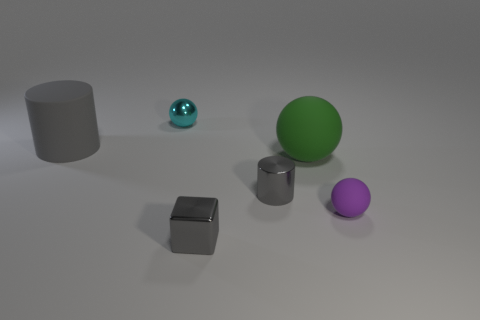The other gray thing that is the same shape as the large gray thing is what size?
Your answer should be very brief. Small. How many tiny blocks are in front of the big thing that is left of the metal thing in front of the purple object?
Your response must be concise. 1. What number of blocks are either large gray things or cyan things?
Ensure brevity in your answer.  0. What is the color of the small thing in front of the rubber ball right of the large object that is to the right of the small cyan thing?
Your response must be concise. Gray. What number of other things are the same size as the gray block?
Give a very brief answer. 3. Is there any other thing that has the same shape as the green matte object?
Ensure brevity in your answer.  Yes. There is another small thing that is the same shape as the tiny matte thing; what color is it?
Your answer should be very brief. Cyan. What is the color of the tiny cube that is made of the same material as the small cyan sphere?
Offer a very short reply. Gray. Are there the same number of big green balls that are behind the large green matte thing and big gray matte cylinders?
Keep it short and to the point. No. There is a green matte object to the right of the rubber cylinder; is it the same size as the big gray matte cylinder?
Make the answer very short. Yes. 